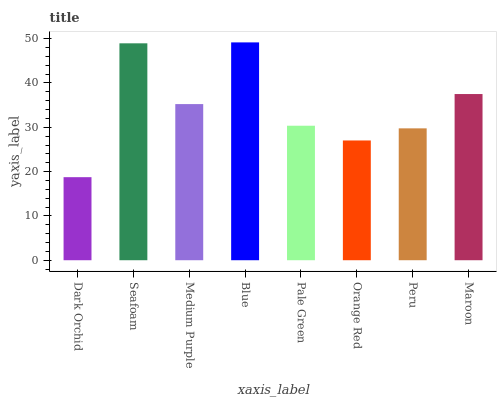Is Dark Orchid the minimum?
Answer yes or no. Yes. Is Blue the maximum?
Answer yes or no. Yes. Is Seafoam the minimum?
Answer yes or no. No. Is Seafoam the maximum?
Answer yes or no. No. Is Seafoam greater than Dark Orchid?
Answer yes or no. Yes. Is Dark Orchid less than Seafoam?
Answer yes or no. Yes. Is Dark Orchid greater than Seafoam?
Answer yes or no. No. Is Seafoam less than Dark Orchid?
Answer yes or no. No. Is Medium Purple the high median?
Answer yes or no. Yes. Is Pale Green the low median?
Answer yes or no. Yes. Is Pale Green the high median?
Answer yes or no. No. Is Blue the low median?
Answer yes or no. No. 